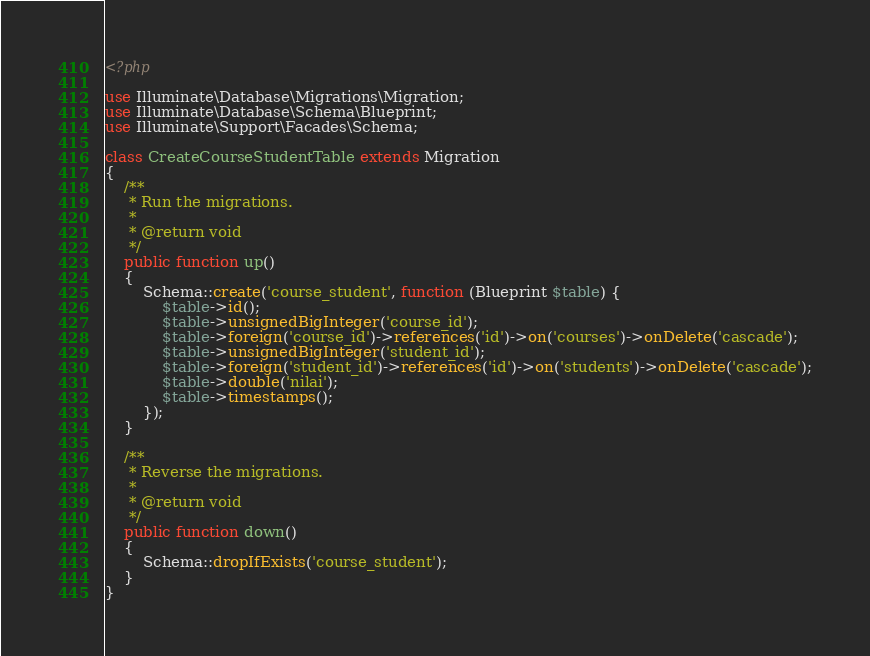<code> <loc_0><loc_0><loc_500><loc_500><_PHP_><?php

use Illuminate\Database\Migrations\Migration;
use Illuminate\Database\Schema\Blueprint;
use Illuminate\Support\Facades\Schema;

class CreateCourseStudentTable extends Migration
{
    /**
     * Run the migrations.
     *
     * @return void
     */
    public function up()
    {
        Schema::create('course_student', function (Blueprint $table) {
            $table->id();
            $table->unsignedBigInteger('course_id');
            $table->foreign('course_id')->references('id')->on('courses')->onDelete('cascade');
            $table->unsignedBigInteger('student_id');
            $table->foreign('student_id')->references('id')->on('students')->onDelete('cascade');
            $table->double('nilai');
            $table->timestamps();
        });
    }

    /**
     * Reverse the migrations.
     *
     * @return void
     */
    public function down()
    {
        Schema::dropIfExists('course_student');
    }
}
</code> 